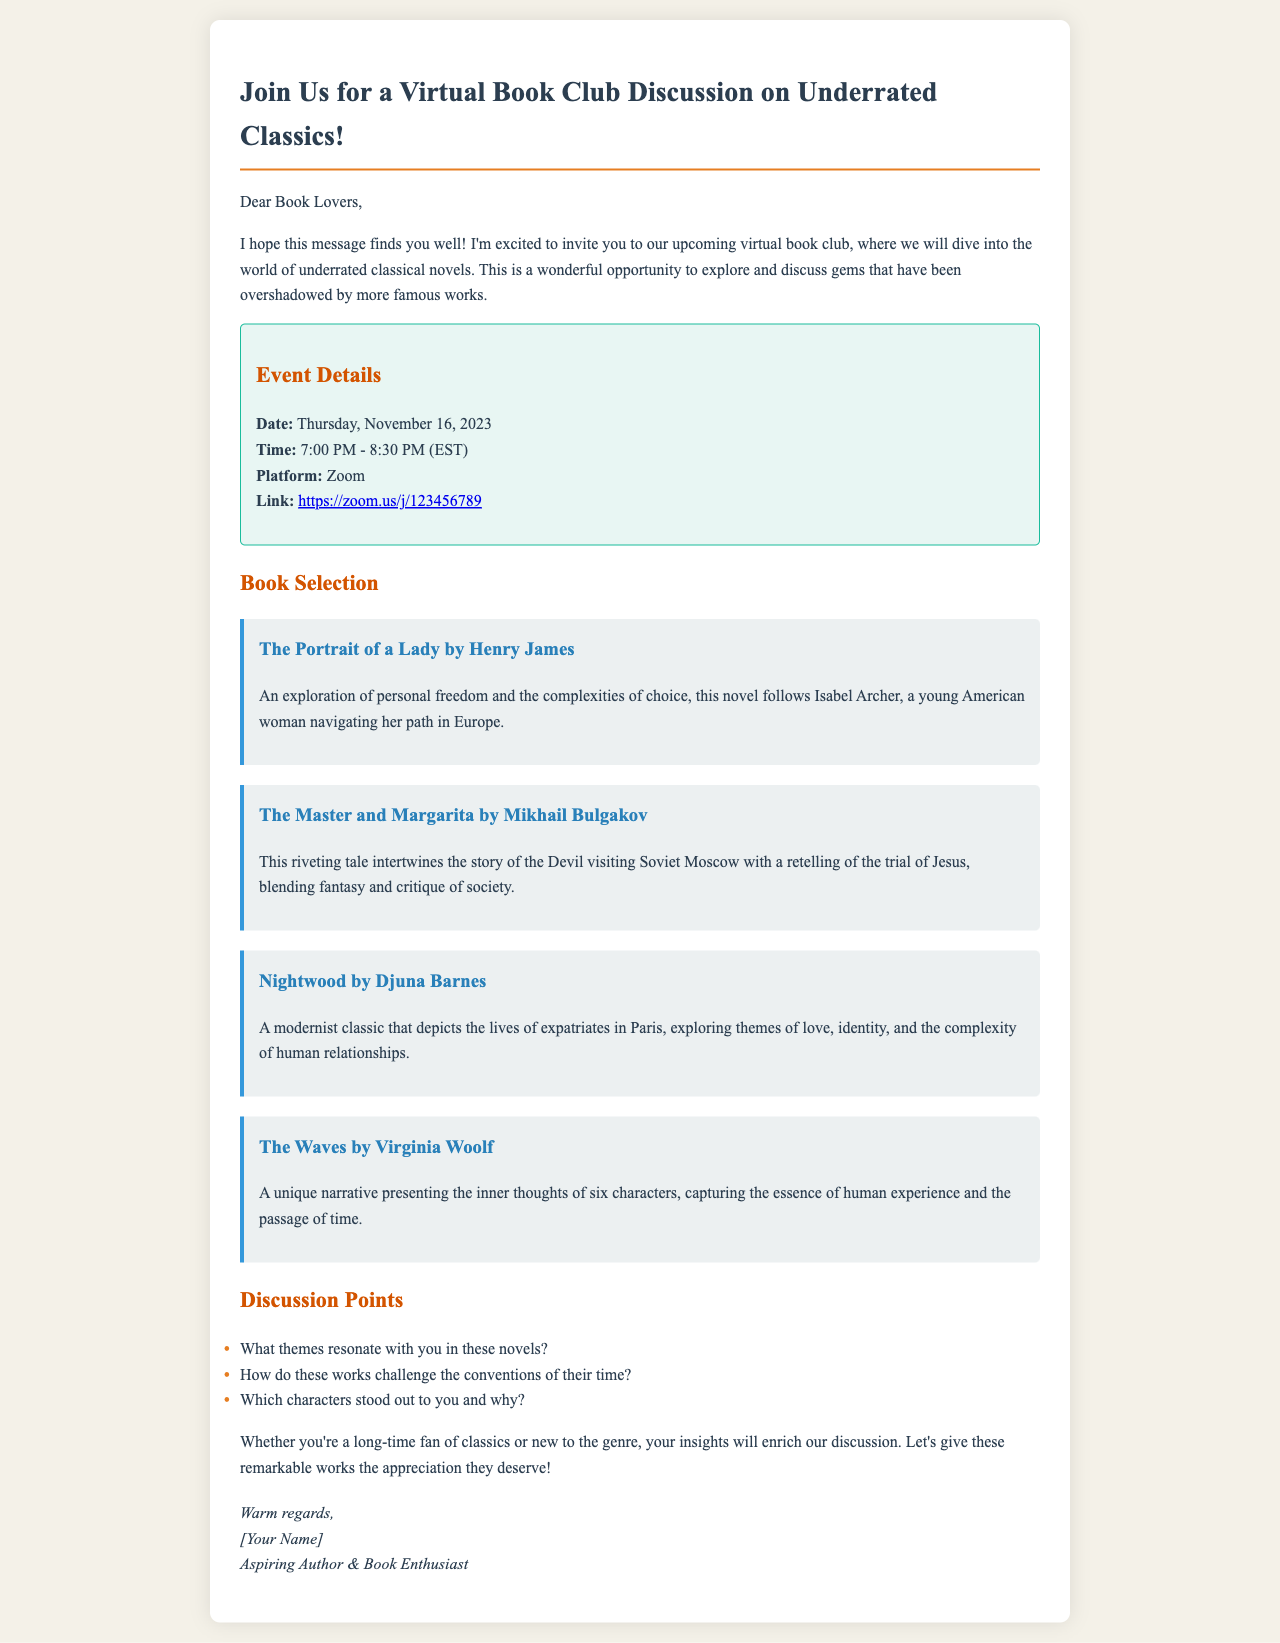What is the date of the virtual book club? The date of the virtual book club is clearly stated in the event details section of the document.
Answer: Thursday, November 16, 2023 What time does the book club start? The starting time is provided alongside the other event details.
Answer: 7:00 PM What platform will be used for the meeting? The platform for the discussion is mentioned in the event details.
Answer: Zoom Who is the author of "Nightwood"? The author of "Nightwood" is listed within the book selection section.
Answer: Djuna Barnes Which novel discusses themes of personal freedom? The description of "The Portrait of a Lady" indicates it explores personal freedom.
Answer: The Portrait of a Lady What is one of the discussion points? A specific discussion point is outlined in the list provided in the document.
Answer: What themes resonate with you in these novels? How many books are listed for discussion? The total number of books can be counted in the book selection section.
Answer: Four What color is used for the border of the event details section? The color used for the border is specified in the style section of the document.
Answer: #1abc9c 